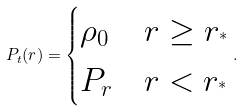<formula> <loc_0><loc_0><loc_500><loc_500>P _ { t } ( r ) = \begin{cases} \rho _ { 0 } & r \geq r _ { ^ { * } } \\ P _ { r } & r < r _ { ^ { * } } \end{cases} .</formula> 